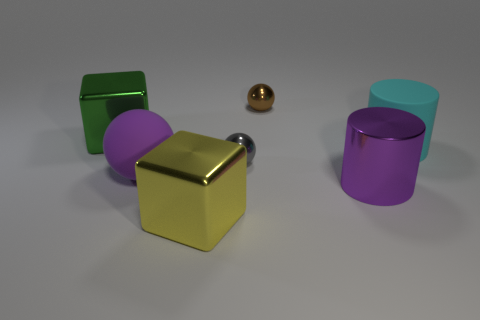There is a shiny cylinder that is the same size as the purple rubber object; what color is it? The shiny cylinder in the image shares its dimensions with the purple object, which has a rubber-like appearance, and it presents a lustrous golden color, reflecting light across its smooth surface. 